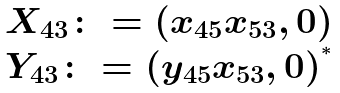<formula> <loc_0><loc_0><loc_500><loc_500>\begin{matrix} X _ { 4 3 } \colon = ( x _ { 4 5 } x _ { 5 3 } , 0 ) \\ Y _ { 4 3 } \colon = ( y _ { 4 5 } x _ { 5 3 } , 0 ) ^ { ^ { * } } \end{matrix}</formula> 